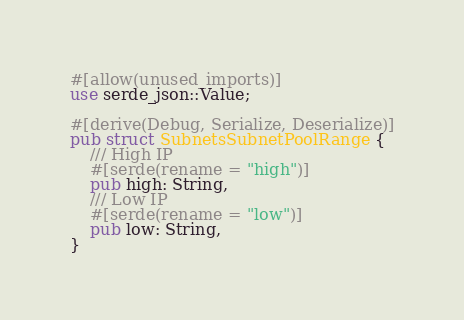<code> <loc_0><loc_0><loc_500><loc_500><_Rust_>#[allow(unused_imports)]
use serde_json::Value;

#[derive(Debug, Serialize, Deserialize)]
pub struct SubnetsSubnetPoolRange {
    /// High IP
    #[serde(rename = "high")]
    pub high: String,
    /// Low IP
    #[serde(rename = "low")]
    pub low: String,
}
</code> 